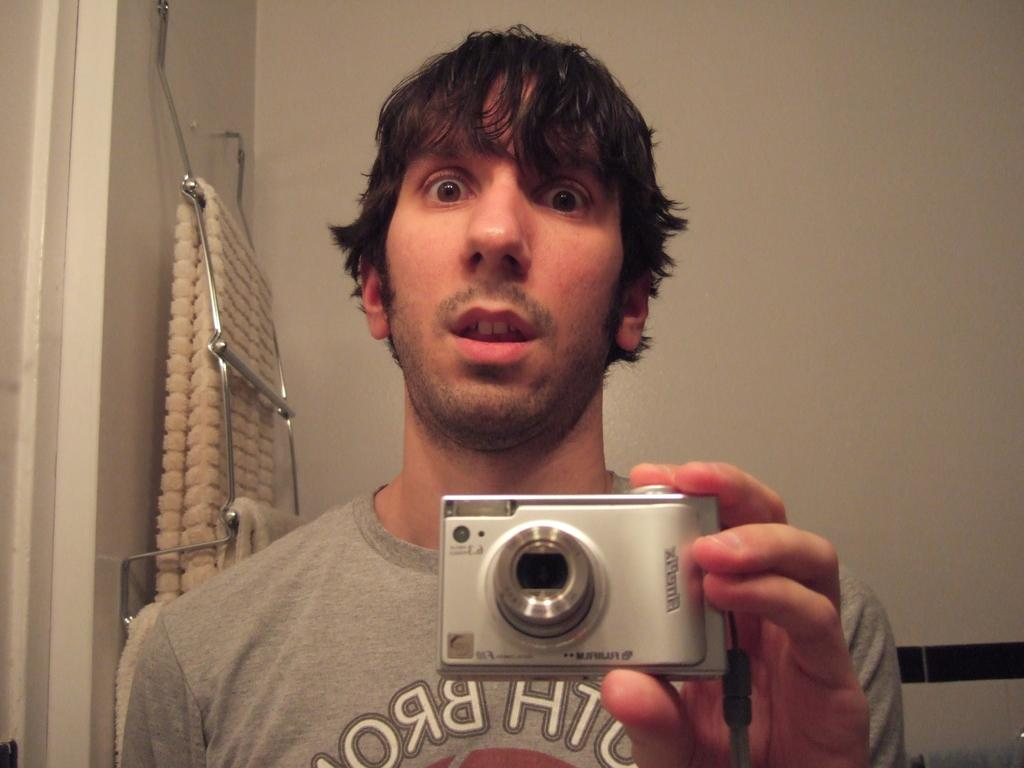Who is present in the image? There is a man in the picture. What is the man doing in the image? The man is standing in the image. What is the man holding in his hands? The man is holding a camera in his hands. What can be seen in the background of the picture? There is a blanket hanging on a hanger in the background of the picture. What scent can be detected from the page in the image? There is no page present in the image, so it is not possible to detect a scent. 